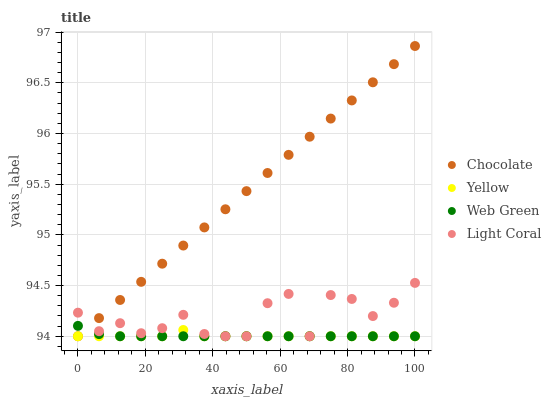Does Yellow have the minimum area under the curve?
Answer yes or no. Yes. Does Chocolate have the maximum area under the curve?
Answer yes or no. Yes. Does Web Green have the minimum area under the curve?
Answer yes or no. No. Does Web Green have the maximum area under the curve?
Answer yes or no. No. Is Chocolate the smoothest?
Answer yes or no. Yes. Is Light Coral the roughest?
Answer yes or no. Yes. Is Web Green the smoothest?
Answer yes or no. No. Is Web Green the roughest?
Answer yes or no. No. Does Light Coral have the lowest value?
Answer yes or no. Yes. Does Chocolate have the highest value?
Answer yes or no. Yes. Does Web Green have the highest value?
Answer yes or no. No. Does Chocolate intersect Yellow?
Answer yes or no. Yes. Is Chocolate less than Yellow?
Answer yes or no. No. Is Chocolate greater than Yellow?
Answer yes or no. No. 